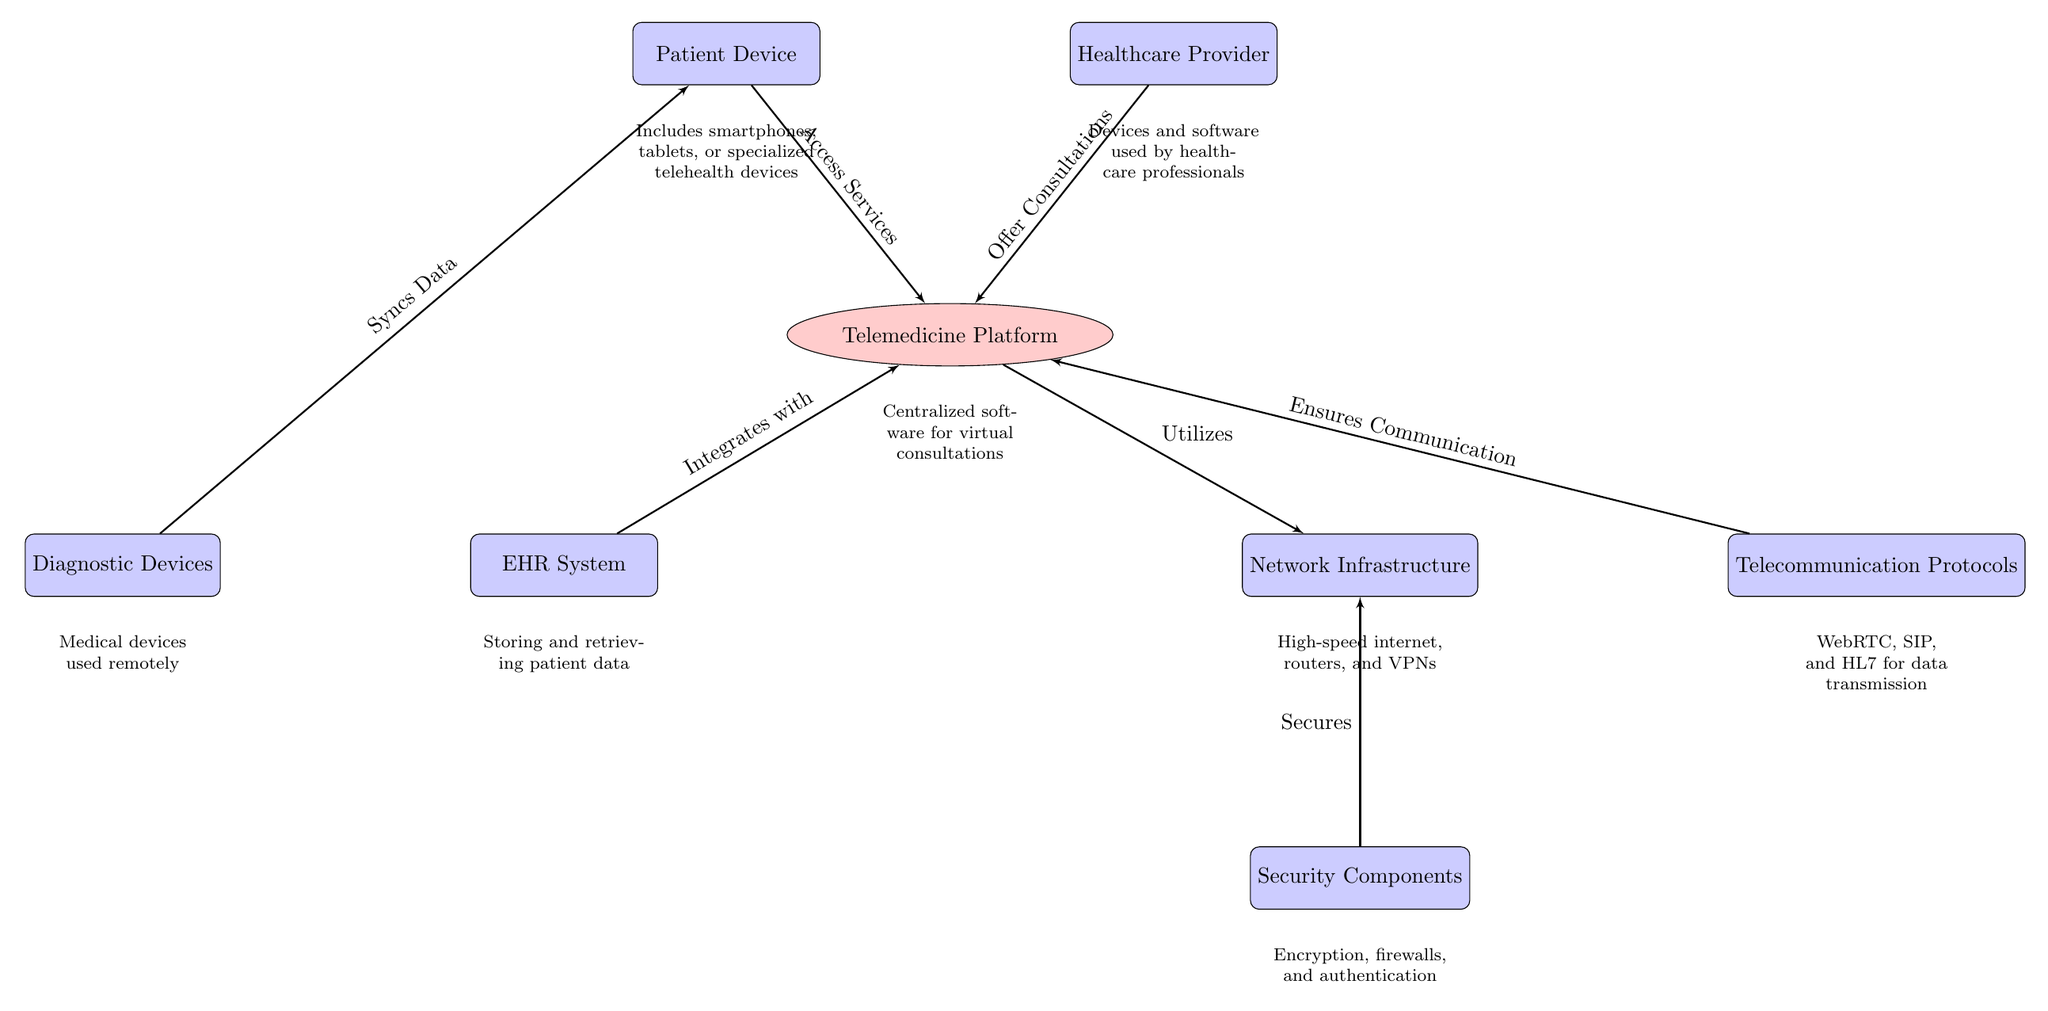What are the two main components represented by the top blocks? The top blocks represent the patient device and healthcare provider, which are key participants in the telemedicine system.
Answer: Patient Device, Healthcare Provider How many nodes are depicted in the diagram? There are eight nodes depicted in the diagram, including the patient device, healthcare provider, telemedicine platform, EHR system, network infrastructure, diagnostic devices, telecommunication protocols, and security components.
Answer: Eight What type of system is the platform classified as in the diagram? The platform is classified as a telemedicine platform, which centralizes software for virtual consultations.
Answer: Telemedicine Platform What do the diagnostic devices sync data with? The diagnostic devices sync data with the patient device, allowing for the transmission of health data from the diagnostic tools directly to the patient's device.
Answer: Patient Device Which component is responsible for data transmission protocols? The component responsible for data transmission protocols is the telecommunication protocols, which ensure communication between various systems in telemedicine.
Answer: Telecommunication Protocols What relationship exists between the EHR system and the telemedicine platform? The EHR system integrates with the telemedicine platform, facilitating the handling and retrieving of patient data within consultations.
Answer: Integrates with What role do security components play in the network? Security components secure the network infrastructure, ensuring that the data transmitted between the patient device, provider, and platform are safeguarded from unauthorized access.
Answer: Secures Which devices are included under 'Patient Device'? The patient device includes smartphones, tablets, or specialized telehealth devices, ensuring diverse access points for patient interaction with telemedicine services.
Answer: Smartphones, tablets, specialized telehealth devices What is the significance of the network infrastructure in the telemedicine diagram? The network infrastructure is significant as it provides the necessary high-speed internet, routers, and VPNs that facilitate communication and data transfer between different components of the telemedicine system.
Answer: High-speed internet, routers, VPNs How is the patient device depicted in relation to diagnostic devices? The patient device is depicted as receiving synced data from diagnostic devices, indicating a direct data flow from those devices into the patient application, which can facilitate remote health monitoring.
Answer: Syncs Data 